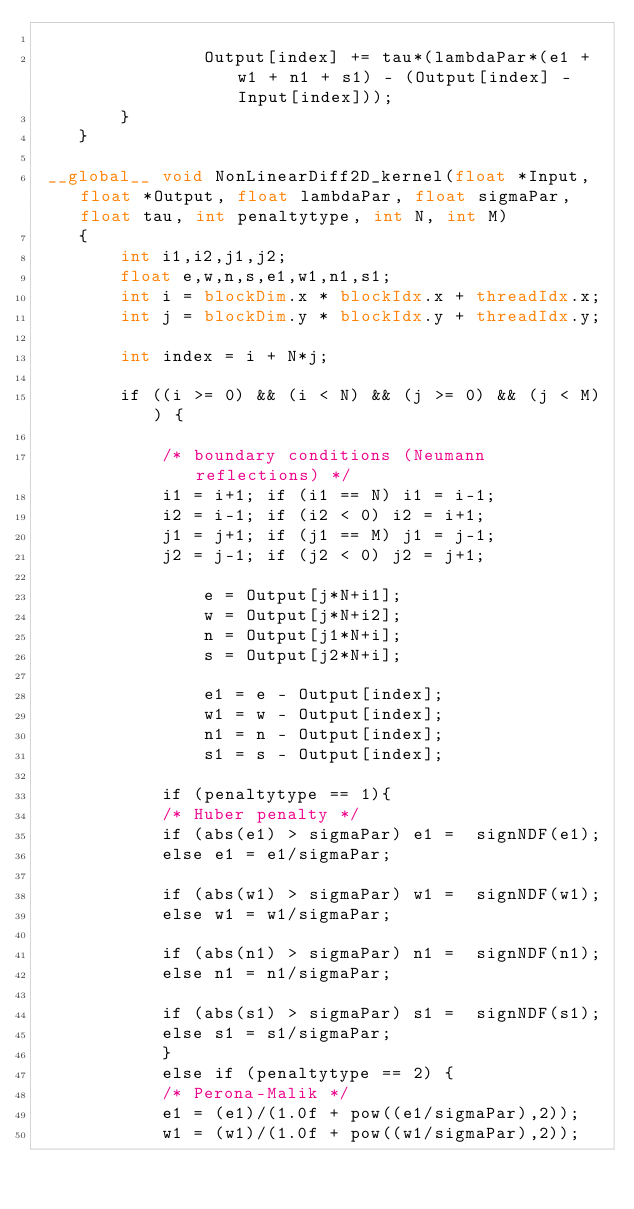Convert code to text. <code><loc_0><loc_0><loc_500><loc_500><_Cuda_>
                Output[index] += tau*(lambdaPar*(e1 + w1 + n1 + s1) - (Output[index] - Input[index]));
		}
	}

 __global__ void NonLinearDiff2D_kernel(float *Input, float *Output, float lambdaPar, float sigmaPar, float tau, int penaltytype, int N, int M)
    {
		int i1,i2,j1,j2;
		float e,w,n,s,e1,w1,n1,s1;
		int i = blockDim.x * blockIdx.x + threadIdx.x;
        int j = blockDim.y * blockIdx.y + threadIdx.y;

        int index = i + N*j;

        if ((i >= 0) && (i < N) && (j >= 0) && (j < M)) {

            /* boundary conditions (Neumann reflections) */
			i1 = i+1; if (i1 == N) i1 = i-1;
			i2 = i-1; if (i2 < 0) i2 = i+1;
            j1 = j+1; if (j1 == M) j1 = j-1;
            j2 = j-1; if (j2 < 0) j2 = j+1;

		        e = Output[j*N+i1];
                w = Output[j*N+i2];
                n = Output[j1*N+i];
                s = Output[j2*N+i];

                e1 = e - Output[index];
                w1 = w - Output[index];
                n1 = n - Output[index];
                s1 = s - Output[index];

            if (penaltytype == 1){
            /* Huber penalty */
            if (abs(e1) > sigmaPar) e1 =  signNDF(e1);
            else e1 = e1/sigmaPar;

            if (abs(w1) > sigmaPar) w1 =  signNDF(w1);
            else w1 = w1/sigmaPar;

            if (abs(n1) > sigmaPar) n1 =  signNDF(n1);
            else n1 = n1/sigmaPar;

            if (abs(s1) > sigmaPar) s1 =  signNDF(s1);
            else s1 = s1/sigmaPar;
            }
            else if (penaltytype == 2) {
            /* Perona-Malik */
            e1 = (e1)/(1.0f + pow((e1/sigmaPar),2));
            w1 = (w1)/(1.0f + pow((w1/sigmaPar),2));</code> 